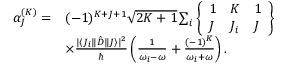<formula> <loc_0><loc_0><loc_500><loc_500>\begin{array} { r l } { \alpha _ { J } ^ { ( K ) } = } & { ( - 1 ) ^ { K + J + 1 } \sqrt { 2 K + 1 } \sum _ { i } \left \{ \begin{array} { l l l } { 1 } & { K } & { 1 } \\ { J } & { J _ { i } } & { J } \end{array} \right \} } \\ & { \times \frac { | \langle J _ { i } \| \hat { D } \| J \rangle | ^ { 2 } } { } \left ( \frac { 1 } { \omega _ { i } - \omega } + \frac { ( - 1 ) ^ { K } } { \omega _ { i } + \omega } \right ) . } \end{array}</formula> 